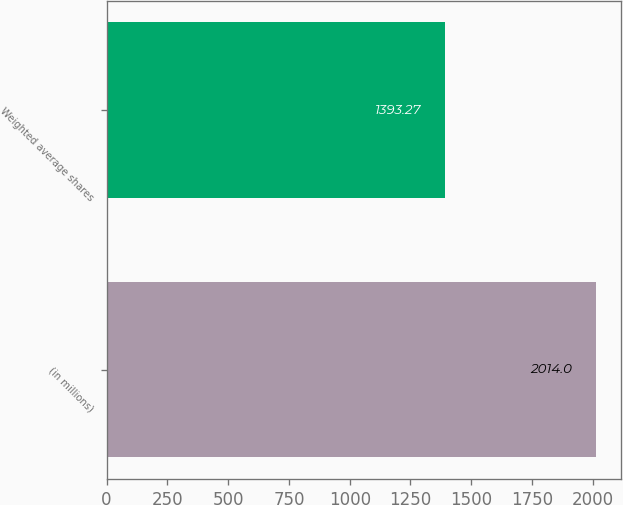Convert chart. <chart><loc_0><loc_0><loc_500><loc_500><bar_chart><fcel>(in millions)<fcel>Weighted average shares<nl><fcel>2014<fcel>1393.27<nl></chart> 